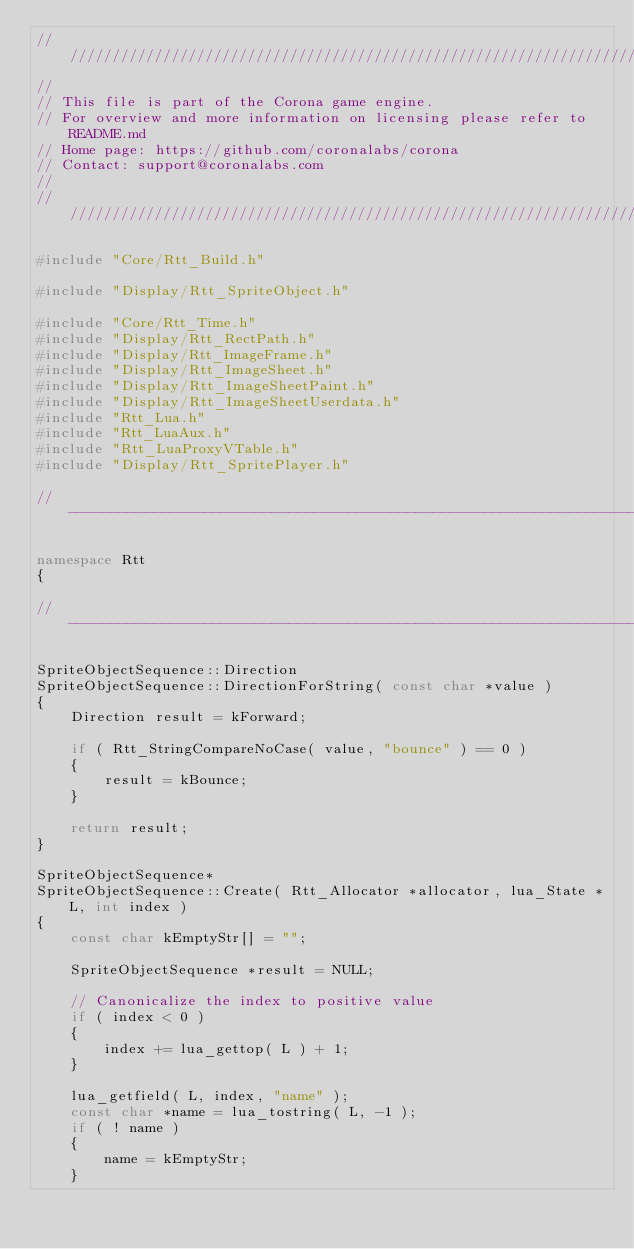<code> <loc_0><loc_0><loc_500><loc_500><_C++_>//////////////////////////////////////////////////////////////////////////////
//
// This file is part of the Corona game engine.
// For overview and more information on licensing please refer to README.md 
// Home page: https://github.com/coronalabs/corona
// Contact: support@coronalabs.com
//
//////////////////////////////////////////////////////////////////////////////

#include "Core/Rtt_Build.h"

#include "Display/Rtt_SpriteObject.h"

#include "Core/Rtt_Time.h"
#include "Display/Rtt_RectPath.h"
#include "Display/Rtt_ImageFrame.h"
#include "Display/Rtt_ImageSheet.h"
#include "Display/Rtt_ImageSheetPaint.h"
#include "Display/Rtt_ImageSheetUserdata.h"
#include "Rtt_Lua.h"
#include "Rtt_LuaAux.h"
#include "Rtt_LuaProxyVTable.h"
#include "Display/Rtt_SpritePlayer.h"

// ----------------------------------------------------------------------------

namespace Rtt
{

// ----------------------------------------------------------------------------

SpriteObjectSequence::Direction
SpriteObjectSequence::DirectionForString( const char *value )
{
	Direction result = kForward;

	if ( Rtt_StringCompareNoCase( value, "bounce" ) == 0 )
	{
		result = kBounce;
	}

	return result;
}

SpriteObjectSequence*
SpriteObjectSequence::Create( Rtt_Allocator *allocator, lua_State *L, int index )
{
	const char kEmptyStr[] = "";

	SpriteObjectSequence *result = NULL;

	// Canonicalize the index to positive value
	if ( index < 0 )
	{
		index += lua_gettop( L ) + 1;
	}

	lua_getfield( L, index, "name" );
	const char *name = lua_tostring( L, -1 );
	if ( ! name )
	{
		name = kEmptyStr;
	}</code> 